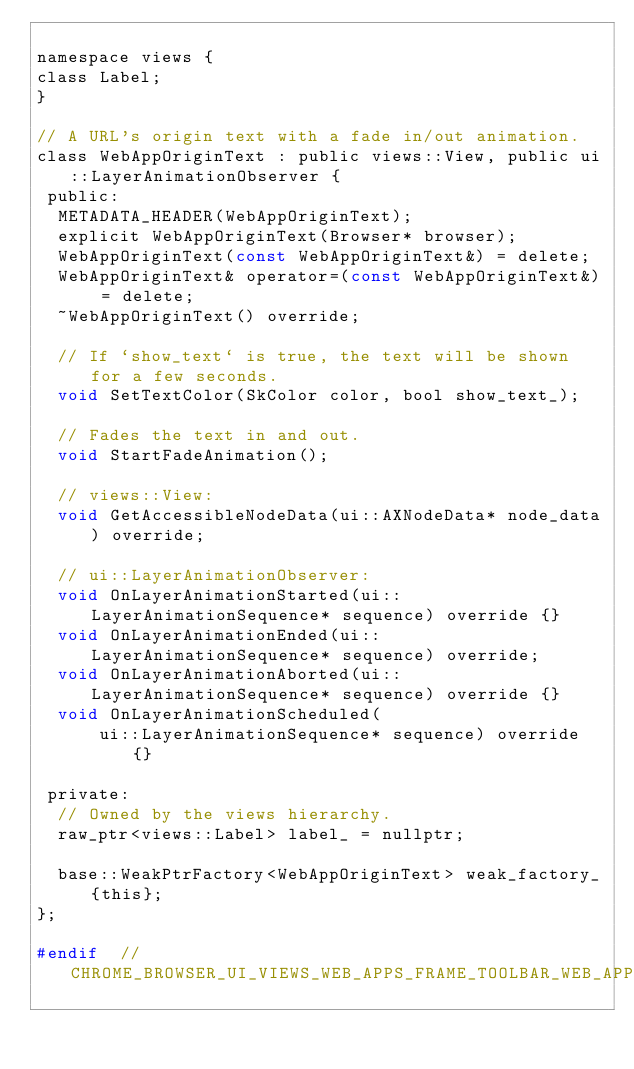<code> <loc_0><loc_0><loc_500><loc_500><_C_>
namespace views {
class Label;
}

// A URL's origin text with a fade in/out animation.
class WebAppOriginText : public views::View, public ui::LayerAnimationObserver {
 public:
  METADATA_HEADER(WebAppOriginText);
  explicit WebAppOriginText(Browser* browser);
  WebAppOriginText(const WebAppOriginText&) = delete;
  WebAppOriginText& operator=(const WebAppOriginText&) = delete;
  ~WebAppOriginText() override;

  // If `show_text` is true, the text will be shown for a few seconds.
  void SetTextColor(SkColor color, bool show_text_);

  // Fades the text in and out.
  void StartFadeAnimation();

  // views::View:
  void GetAccessibleNodeData(ui::AXNodeData* node_data) override;

  // ui::LayerAnimationObserver:
  void OnLayerAnimationStarted(ui::LayerAnimationSequence* sequence) override {}
  void OnLayerAnimationEnded(ui::LayerAnimationSequence* sequence) override;
  void OnLayerAnimationAborted(ui::LayerAnimationSequence* sequence) override {}
  void OnLayerAnimationScheduled(
      ui::LayerAnimationSequence* sequence) override {}

 private:
  // Owned by the views hierarchy.
  raw_ptr<views::Label> label_ = nullptr;

  base::WeakPtrFactory<WebAppOriginText> weak_factory_{this};
};

#endif  // CHROME_BROWSER_UI_VIEWS_WEB_APPS_FRAME_TOOLBAR_WEB_APP_ORIGIN_TEXT_H_
</code> 